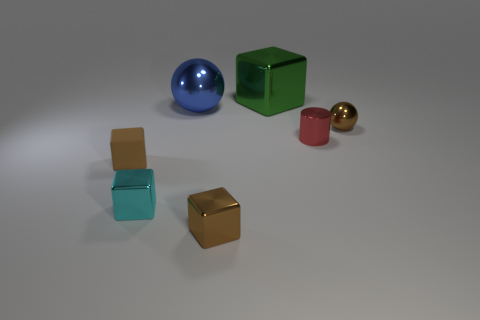There is a tiny shiny object to the left of the brown metal block; is it the same color as the rubber block?
Provide a succinct answer. No. What size is the other thing that is the same shape as the large blue thing?
Keep it short and to the point. Small. What color is the shiny sphere on the left side of the shiny cube behind the sphere right of the big blue metallic sphere?
Provide a short and direct response. Blue. Is the small cylinder made of the same material as the green object?
Make the answer very short. Yes. There is a brown shiny thing left of the block that is behind the tiny red shiny object; is there a large blue thing left of it?
Provide a short and direct response. Yes. Is the color of the big cube the same as the shiny cylinder?
Your answer should be compact. No. Is the number of small cyan cubes less than the number of big brown spheres?
Offer a terse response. No. Is the ball on the left side of the tiny metal ball made of the same material as the cyan thing that is in front of the tiny red thing?
Make the answer very short. Yes. Is the number of big blue spheres behind the large green metal object less than the number of tiny blocks?
Offer a very short reply. Yes. There is a tiny brown metal object that is in front of the rubber thing; how many brown things are left of it?
Offer a very short reply. 1. 